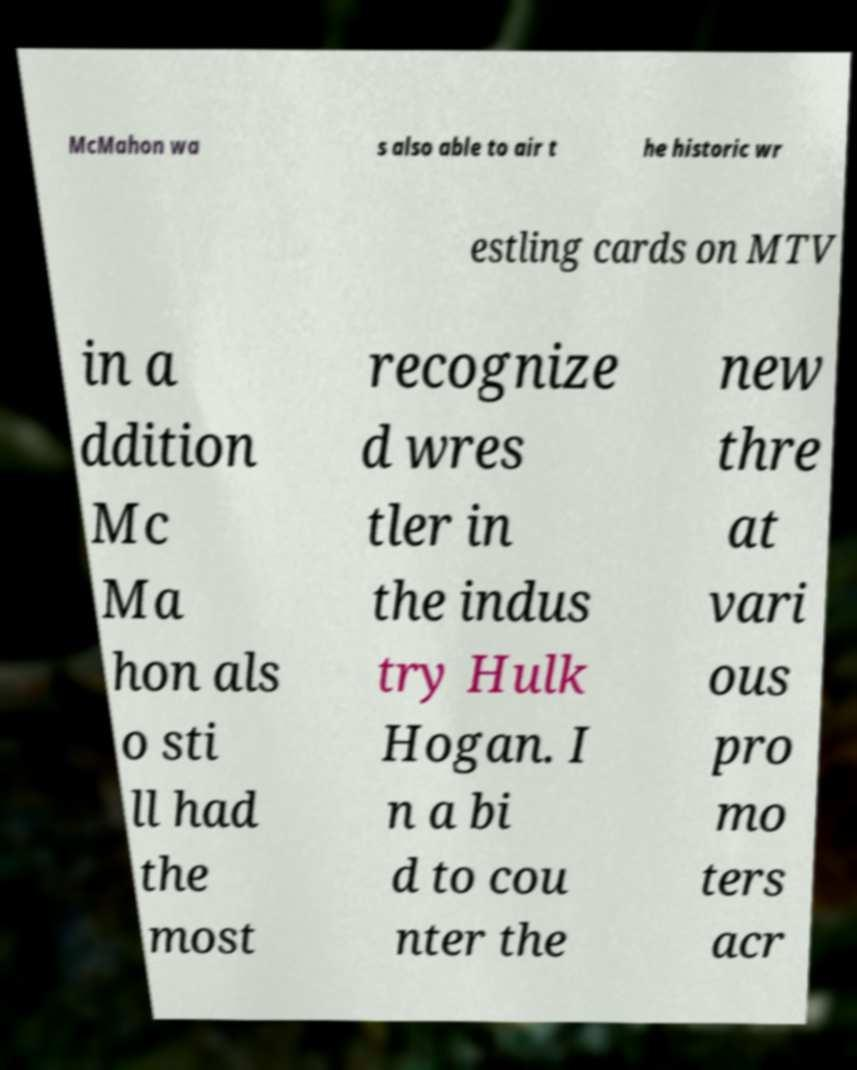There's text embedded in this image that I need extracted. Can you transcribe it verbatim? McMahon wa s also able to air t he historic wr estling cards on MTV in a ddition Mc Ma hon als o sti ll had the most recognize d wres tler in the indus try Hulk Hogan. I n a bi d to cou nter the new thre at vari ous pro mo ters acr 